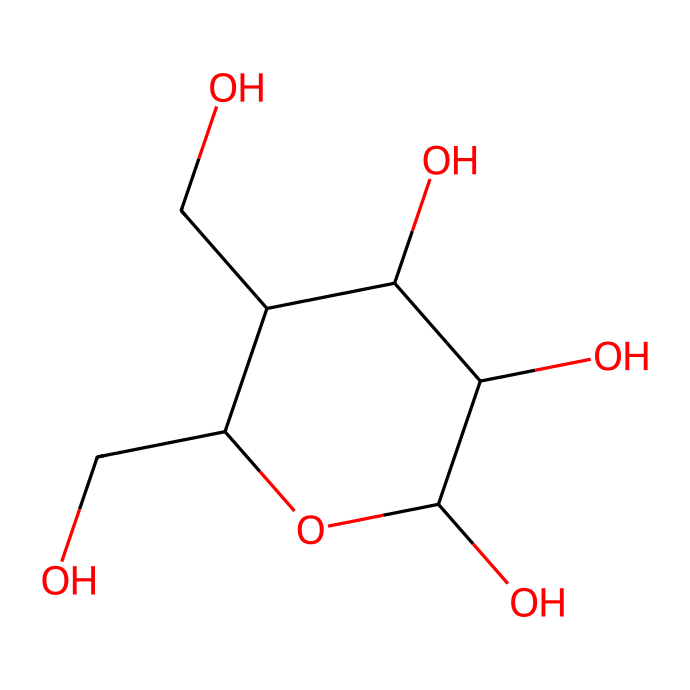What is the chemical name of this structure? The SMILES representation corresponds to a molecule with hydroxyl (OH) groups and a specific carbon arrangement indicative of vitamin C, also known as ascorbic acid.
Answer: ascorbic acid How many carbon atoms are present in the structure? By analyzing the carbon atoms denoted by 'C' in the SMILES string, we can count them. There are 6 carbon atoms represented in the chemical structure.
Answer: 6 What is the highest degree of branching in this structure? Upon examination of the carbon chain, branching occurs at one of the carbon atoms; thus, with the connectivity shown, the highest degree of branching is determined to be 1.
Answer: 1 How many hydroxyl (–OH) groups are attached to the carbon framework? In the structure, by identifying the 'O' atoms that connect to hydrogen atoms (OH groups) in the SMILES, we find that there are 4 hydroxyl groups present.
Answer: 4 What type of functional groups are prominent in this molecule? The structure features hydroxyl groups primarily, which are characteristic of alcohols, indicating that this molecule is alcohol-rich.
Answer: hydroxyl groups Which topological property might this structure exhibit related to its cyclic component? The cyclic component of the structure implies a potential for higher connectivity and loop features in topological analysis, suggesting it might exhibit characteristics such as chirality in terms of algebraic topology.
Answer: chirality 